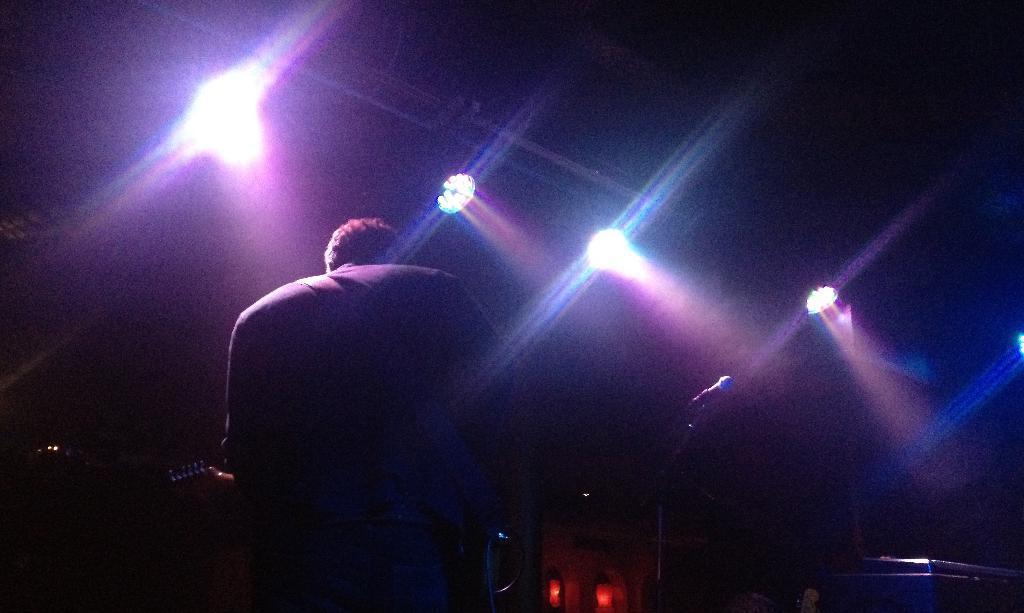In one or two sentences, can you explain what this image depicts? In this image we can see a man standing holding the musical instrument. We can also see a mic with a stand, a device on a table and some lights. 